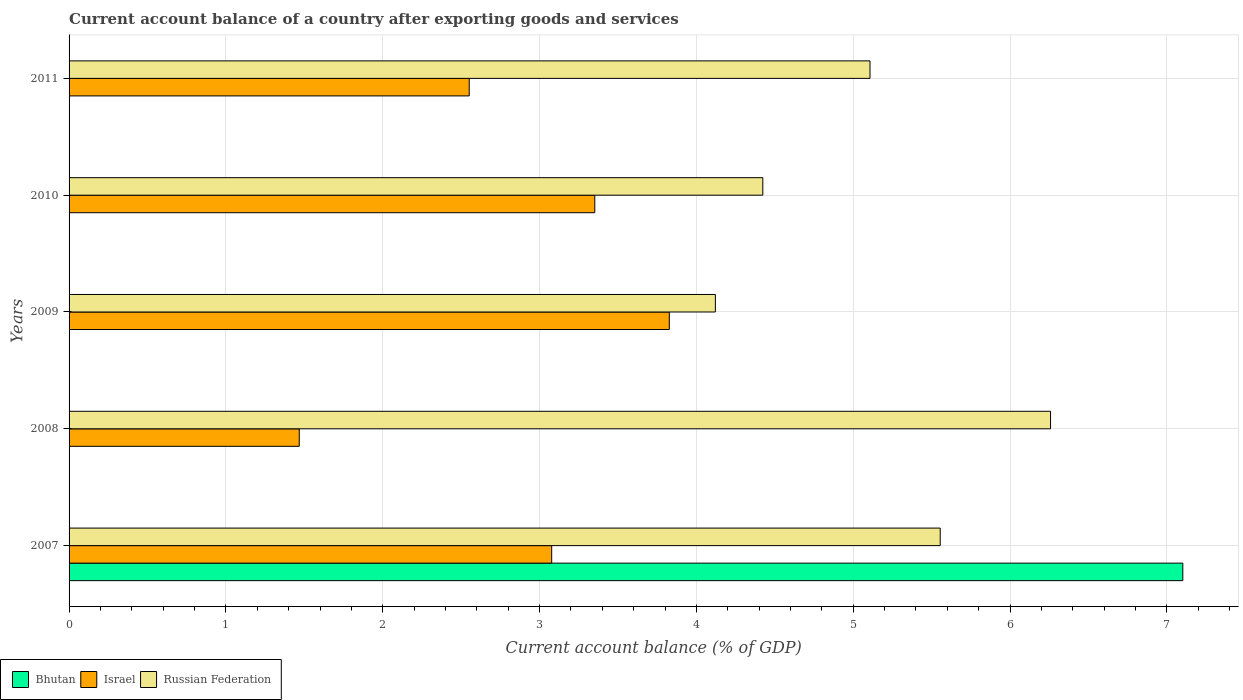How many groups of bars are there?
Provide a succinct answer. 5. Are the number of bars on each tick of the Y-axis equal?
Offer a terse response. No. How many bars are there on the 2nd tick from the top?
Offer a terse response. 2. What is the label of the 3rd group of bars from the top?
Your answer should be compact. 2009. In how many cases, is the number of bars for a given year not equal to the number of legend labels?
Give a very brief answer. 4. What is the account balance in Russian Federation in 2009?
Make the answer very short. 4.12. Across all years, what is the maximum account balance in Bhutan?
Ensure brevity in your answer.  7.1. Across all years, what is the minimum account balance in Israel?
Keep it short and to the point. 1.47. In which year was the account balance in Bhutan maximum?
Provide a succinct answer. 2007. What is the total account balance in Israel in the graph?
Provide a succinct answer. 14.28. What is the difference between the account balance in Israel in 2008 and that in 2011?
Offer a very short reply. -1.08. What is the difference between the account balance in Russian Federation in 2009 and the account balance in Bhutan in 2008?
Give a very brief answer. 4.12. What is the average account balance in Israel per year?
Your response must be concise. 2.86. In the year 2007, what is the difference between the account balance in Russian Federation and account balance in Bhutan?
Your answer should be very brief. -1.55. What is the ratio of the account balance in Israel in 2009 to that in 2011?
Offer a terse response. 1.5. What is the difference between the highest and the second highest account balance in Israel?
Offer a very short reply. 0.48. What is the difference between the highest and the lowest account balance in Russian Federation?
Offer a very short reply. 2.14. In how many years, is the account balance in Bhutan greater than the average account balance in Bhutan taken over all years?
Make the answer very short. 1. How many years are there in the graph?
Provide a succinct answer. 5. Does the graph contain any zero values?
Your answer should be compact. Yes. How are the legend labels stacked?
Your answer should be compact. Horizontal. What is the title of the graph?
Offer a terse response. Current account balance of a country after exporting goods and services. What is the label or title of the X-axis?
Give a very brief answer. Current account balance (% of GDP). What is the label or title of the Y-axis?
Make the answer very short. Years. What is the Current account balance (% of GDP) in Bhutan in 2007?
Keep it short and to the point. 7.1. What is the Current account balance (% of GDP) of Israel in 2007?
Your response must be concise. 3.08. What is the Current account balance (% of GDP) of Russian Federation in 2007?
Offer a terse response. 5.55. What is the Current account balance (% of GDP) in Israel in 2008?
Offer a very short reply. 1.47. What is the Current account balance (% of GDP) in Russian Federation in 2008?
Provide a short and direct response. 6.26. What is the Current account balance (% of GDP) in Israel in 2009?
Your answer should be very brief. 3.83. What is the Current account balance (% of GDP) in Russian Federation in 2009?
Make the answer very short. 4.12. What is the Current account balance (% of GDP) in Israel in 2010?
Provide a short and direct response. 3.35. What is the Current account balance (% of GDP) of Russian Federation in 2010?
Your answer should be very brief. 4.42. What is the Current account balance (% of GDP) of Israel in 2011?
Provide a short and direct response. 2.55. What is the Current account balance (% of GDP) of Russian Federation in 2011?
Keep it short and to the point. 5.11. Across all years, what is the maximum Current account balance (% of GDP) of Bhutan?
Offer a very short reply. 7.1. Across all years, what is the maximum Current account balance (% of GDP) of Israel?
Offer a terse response. 3.83. Across all years, what is the maximum Current account balance (% of GDP) of Russian Federation?
Offer a terse response. 6.26. Across all years, what is the minimum Current account balance (% of GDP) of Bhutan?
Your response must be concise. 0. Across all years, what is the minimum Current account balance (% of GDP) of Israel?
Make the answer very short. 1.47. Across all years, what is the minimum Current account balance (% of GDP) in Russian Federation?
Offer a terse response. 4.12. What is the total Current account balance (% of GDP) of Bhutan in the graph?
Your response must be concise. 7.1. What is the total Current account balance (% of GDP) of Israel in the graph?
Your answer should be very brief. 14.28. What is the total Current account balance (% of GDP) in Russian Federation in the graph?
Keep it short and to the point. 25.46. What is the difference between the Current account balance (% of GDP) in Israel in 2007 and that in 2008?
Offer a very short reply. 1.61. What is the difference between the Current account balance (% of GDP) in Russian Federation in 2007 and that in 2008?
Offer a very short reply. -0.7. What is the difference between the Current account balance (% of GDP) of Israel in 2007 and that in 2009?
Offer a very short reply. -0.75. What is the difference between the Current account balance (% of GDP) in Russian Federation in 2007 and that in 2009?
Give a very brief answer. 1.43. What is the difference between the Current account balance (% of GDP) in Israel in 2007 and that in 2010?
Offer a very short reply. -0.27. What is the difference between the Current account balance (% of GDP) in Russian Federation in 2007 and that in 2010?
Keep it short and to the point. 1.13. What is the difference between the Current account balance (% of GDP) in Israel in 2007 and that in 2011?
Keep it short and to the point. 0.53. What is the difference between the Current account balance (% of GDP) of Russian Federation in 2007 and that in 2011?
Your response must be concise. 0.45. What is the difference between the Current account balance (% of GDP) of Israel in 2008 and that in 2009?
Provide a succinct answer. -2.36. What is the difference between the Current account balance (% of GDP) in Russian Federation in 2008 and that in 2009?
Provide a succinct answer. 2.14. What is the difference between the Current account balance (% of GDP) of Israel in 2008 and that in 2010?
Your answer should be compact. -1.88. What is the difference between the Current account balance (% of GDP) in Russian Federation in 2008 and that in 2010?
Ensure brevity in your answer.  1.83. What is the difference between the Current account balance (% of GDP) of Israel in 2008 and that in 2011?
Offer a terse response. -1.08. What is the difference between the Current account balance (% of GDP) in Russian Federation in 2008 and that in 2011?
Ensure brevity in your answer.  1.15. What is the difference between the Current account balance (% of GDP) in Israel in 2009 and that in 2010?
Your answer should be very brief. 0.48. What is the difference between the Current account balance (% of GDP) in Russian Federation in 2009 and that in 2010?
Ensure brevity in your answer.  -0.3. What is the difference between the Current account balance (% of GDP) in Israel in 2009 and that in 2011?
Ensure brevity in your answer.  1.28. What is the difference between the Current account balance (% of GDP) of Russian Federation in 2009 and that in 2011?
Make the answer very short. -0.99. What is the difference between the Current account balance (% of GDP) of Israel in 2010 and that in 2011?
Give a very brief answer. 0.8. What is the difference between the Current account balance (% of GDP) in Russian Federation in 2010 and that in 2011?
Your response must be concise. -0.68. What is the difference between the Current account balance (% of GDP) of Bhutan in 2007 and the Current account balance (% of GDP) of Israel in 2008?
Provide a short and direct response. 5.63. What is the difference between the Current account balance (% of GDP) of Bhutan in 2007 and the Current account balance (% of GDP) of Russian Federation in 2008?
Provide a succinct answer. 0.84. What is the difference between the Current account balance (% of GDP) of Israel in 2007 and the Current account balance (% of GDP) of Russian Federation in 2008?
Provide a short and direct response. -3.18. What is the difference between the Current account balance (% of GDP) in Bhutan in 2007 and the Current account balance (% of GDP) in Israel in 2009?
Make the answer very short. 3.27. What is the difference between the Current account balance (% of GDP) of Bhutan in 2007 and the Current account balance (% of GDP) of Russian Federation in 2009?
Keep it short and to the point. 2.98. What is the difference between the Current account balance (% of GDP) in Israel in 2007 and the Current account balance (% of GDP) in Russian Federation in 2009?
Provide a succinct answer. -1.04. What is the difference between the Current account balance (% of GDP) of Bhutan in 2007 and the Current account balance (% of GDP) of Israel in 2010?
Your answer should be compact. 3.75. What is the difference between the Current account balance (% of GDP) in Bhutan in 2007 and the Current account balance (% of GDP) in Russian Federation in 2010?
Provide a succinct answer. 2.68. What is the difference between the Current account balance (% of GDP) in Israel in 2007 and the Current account balance (% of GDP) in Russian Federation in 2010?
Your answer should be very brief. -1.35. What is the difference between the Current account balance (% of GDP) in Bhutan in 2007 and the Current account balance (% of GDP) in Israel in 2011?
Offer a very short reply. 4.55. What is the difference between the Current account balance (% of GDP) of Bhutan in 2007 and the Current account balance (% of GDP) of Russian Federation in 2011?
Your answer should be very brief. 1.99. What is the difference between the Current account balance (% of GDP) of Israel in 2007 and the Current account balance (% of GDP) of Russian Federation in 2011?
Provide a succinct answer. -2.03. What is the difference between the Current account balance (% of GDP) of Israel in 2008 and the Current account balance (% of GDP) of Russian Federation in 2009?
Your response must be concise. -2.65. What is the difference between the Current account balance (% of GDP) of Israel in 2008 and the Current account balance (% of GDP) of Russian Federation in 2010?
Make the answer very short. -2.96. What is the difference between the Current account balance (% of GDP) of Israel in 2008 and the Current account balance (% of GDP) of Russian Federation in 2011?
Keep it short and to the point. -3.64. What is the difference between the Current account balance (% of GDP) in Israel in 2009 and the Current account balance (% of GDP) in Russian Federation in 2010?
Offer a terse response. -0.6. What is the difference between the Current account balance (% of GDP) in Israel in 2009 and the Current account balance (% of GDP) in Russian Federation in 2011?
Offer a very short reply. -1.28. What is the difference between the Current account balance (% of GDP) in Israel in 2010 and the Current account balance (% of GDP) in Russian Federation in 2011?
Keep it short and to the point. -1.75. What is the average Current account balance (% of GDP) in Bhutan per year?
Provide a short and direct response. 1.42. What is the average Current account balance (% of GDP) in Israel per year?
Your response must be concise. 2.86. What is the average Current account balance (% of GDP) of Russian Federation per year?
Your answer should be very brief. 5.09. In the year 2007, what is the difference between the Current account balance (% of GDP) in Bhutan and Current account balance (% of GDP) in Israel?
Your response must be concise. 4.02. In the year 2007, what is the difference between the Current account balance (% of GDP) in Bhutan and Current account balance (% of GDP) in Russian Federation?
Your answer should be very brief. 1.55. In the year 2007, what is the difference between the Current account balance (% of GDP) in Israel and Current account balance (% of GDP) in Russian Federation?
Provide a short and direct response. -2.48. In the year 2008, what is the difference between the Current account balance (% of GDP) in Israel and Current account balance (% of GDP) in Russian Federation?
Give a very brief answer. -4.79. In the year 2009, what is the difference between the Current account balance (% of GDP) in Israel and Current account balance (% of GDP) in Russian Federation?
Your response must be concise. -0.29. In the year 2010, what is the difference between the Current account balance (% of GDP) in Israel and Current account balance (% of GDP) in Russian Federation?
Provide a short and direct response. -1.07. In the year 2011, what is the difference between the Current account balance (% of GDP) in Israel and Current account balance (% of GDP) in Russian Federation?
Provide a short and direct response. -2.56. What is the ratio of the Current account balance (% of GDP) of Israel in 2007 to that in 2008?
Your response must be concise. 2.1. What is the ratio of the Current account balance (% of GDP) of Russian Federation in 2007 to that in 2008?
Make the answer very short. 0.89. What is the ratio of the Current account balance (% of GDP) of Israel in 2007 to that in 2009?
Ensure brevity in your answer.  0.8. What is the ratio of the Current account balance (% of GDP) in Russian Federation in 2007 to that in 2009?
Give a very brief answer. 1.35. What is the ratio of the Current account balance (% of GDP) of Israel in 2007 to that in 2010?
Make the answer very short. 0.92. What is the ratio of the Current account balance (% of GDP) in Russian Federation in 2007 to that in 2010?
Offer a terse response. 1.26. What is the ratio of the Current account balance (% of GDP) of Israel in 2007 to that in 2011?
Ensure brevity in your answer.  1.21. What is the ratio of the Current account balance (% of GDP) of Russian Federation in 2007 to that in 2011?
Provide a short and direct response. 1.09. What is the ratio of the Current account balance (% of GDP) in Israel in 2008 to that in 2009?
Offer a terse response. 0.38. What is the ratio of the Current account balance (% of GDP) in Russian Federation in 2008 to that in 2009?
Your answer should be very brief. 1.52. What is the ratio of the Current account balance (% of GDP) in Israel in 2008 to that in 2010?
Provide a short and direct response. 0.44. What is the ratio of the Current account balance (% of GDP) in Russian Federation in 2008 to that in 2010?
Keep it short and to the point. 1.41. What is the ratio of the Current account balance (% of GDP) in Israel in 2008 to that in 2011?
Offer a terse response. 0.58. What is the ratio of the Current account balance (% of GDP) of Russian Federation in 2008 to that in 2011?
Provide a succinct answer. 1.23. What is the ratio of the Current account balance (% of GDP) of Israel in 2009 to that in 2010?
Keep it short and to the point. 1.14. What is the ratio of the Current account balance (% of GDP) in Russian Federation in 2009 to that in 2010?
Give a very brief answer. 0.93. What is the ratio of the Current account balance (% of GDP) of Israel in 2009 to that in 2011?
Your response must be concise. 1.5. What is the ratio of the Current account balance (% of GDP) in Russian Federation in 2009 to that in 2011?
Keep it short and to the point. 0.81. What is the ratio of the Current account balance (% of GDP) of Israel in 2010 to that in 2011?
Your answer should be compact. 1.31. What is the ratio of the Current account balance (% of GDP) of Russian Federation in 2010 to that in 2011?
Your answer should be compact. 0.87. What is the difference between the highest and the second highest Current account balance (% of GDP) of Israel?
Offer a very short reply. 0.48. What is the difference between the highest and the second highest Current account balance (% of GDP) in Russian Federation?
Your answer should be compact. 0.7. What is the difference between the highest and the lowest Current account balance (% of GDP) in Bhutan?
Your answer should be compact. 7.1. What is the difference between the highest and the lowest Current account balance (% of GDP) in Israel?
Your response must be concise. 2.36. What is the difference between the highest and the lowest Current account balance (% of GDP) of Russian Federation?
Provide a succinct answer. 2.14. 